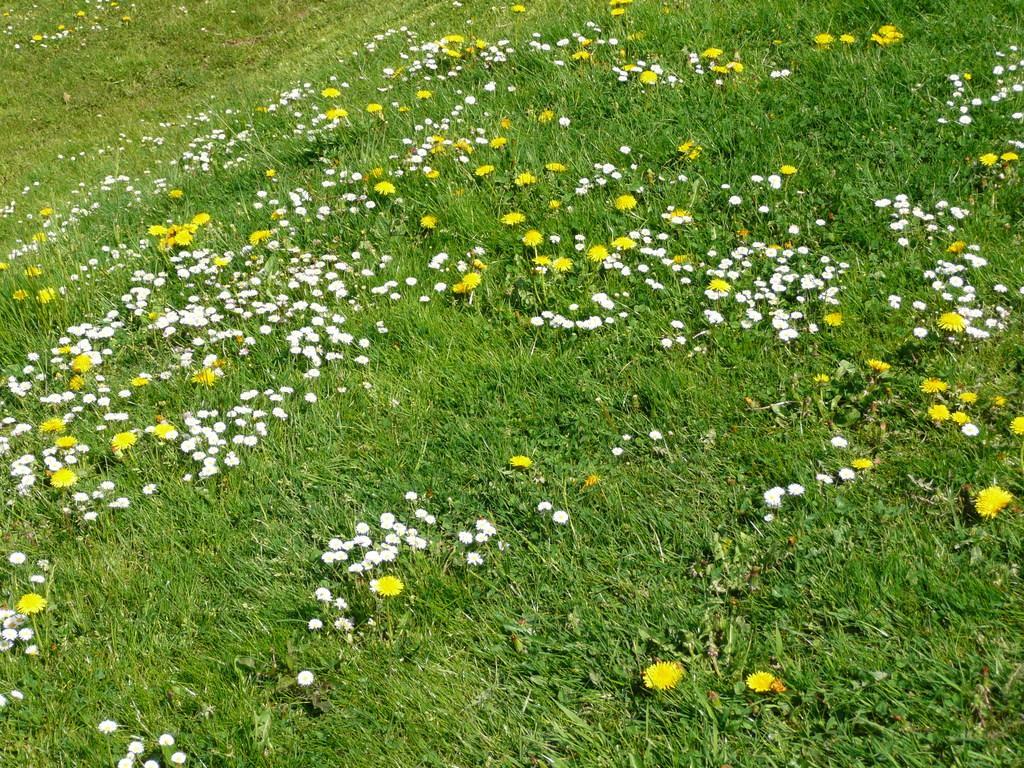Can you describe this image briefly? In this picture we can see grass and flowers. 